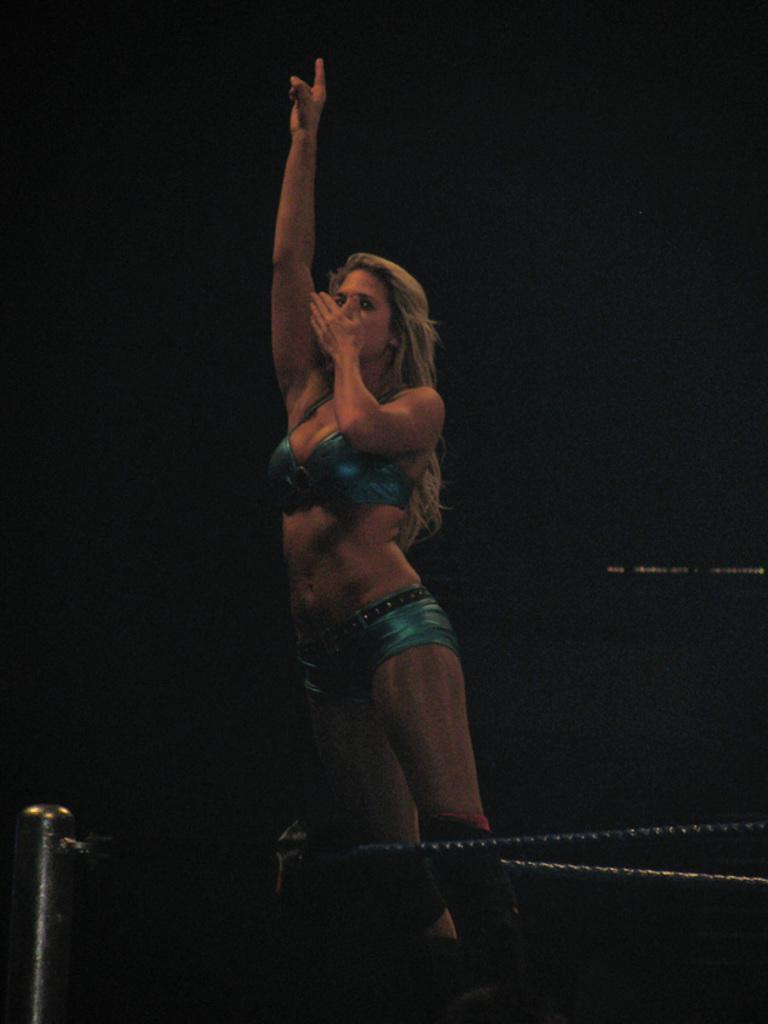Who is the main subject in the image? There is a woman in the image. What is the woman standing on? The woman is standing on a dais. Where is the dais located in the image? The dais is in the center of the image. What type of print can be seen on the woman's shirt in the image? There is no print visible on the woman's shirt in the image. What type of gate is present in the image? There is no gate present in the image. 